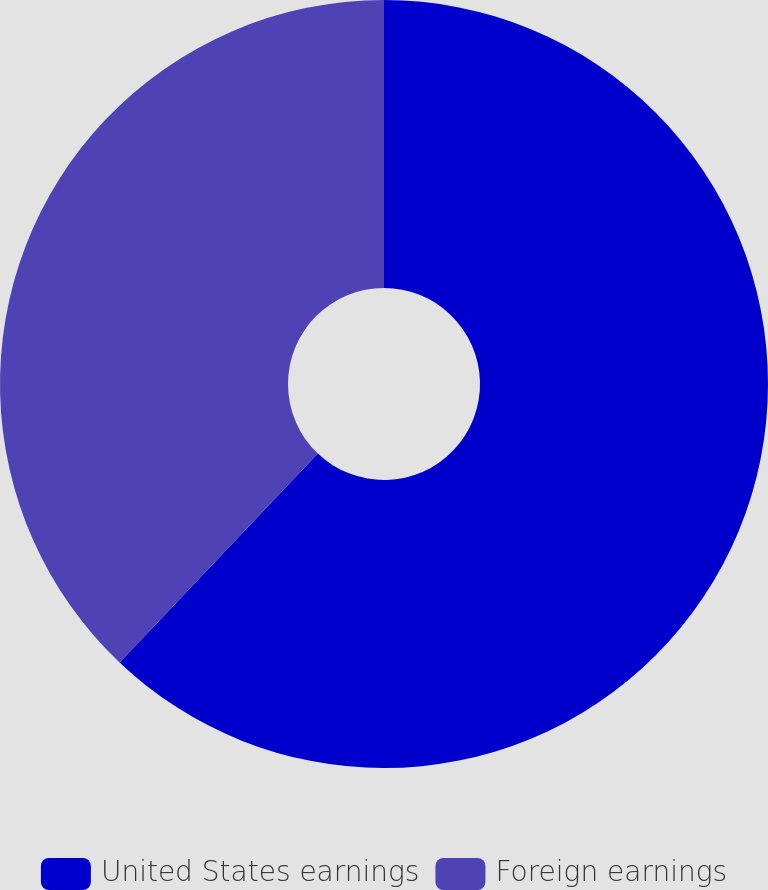Convert chart to OTSL. <chart><loc_0><loc_0><loc_500><loc_500><pie_chart><fcel>United States earnings<fcel>Foreign earnings<nl><fcel>62.09%<fcel>37.91%<nl></chart> 